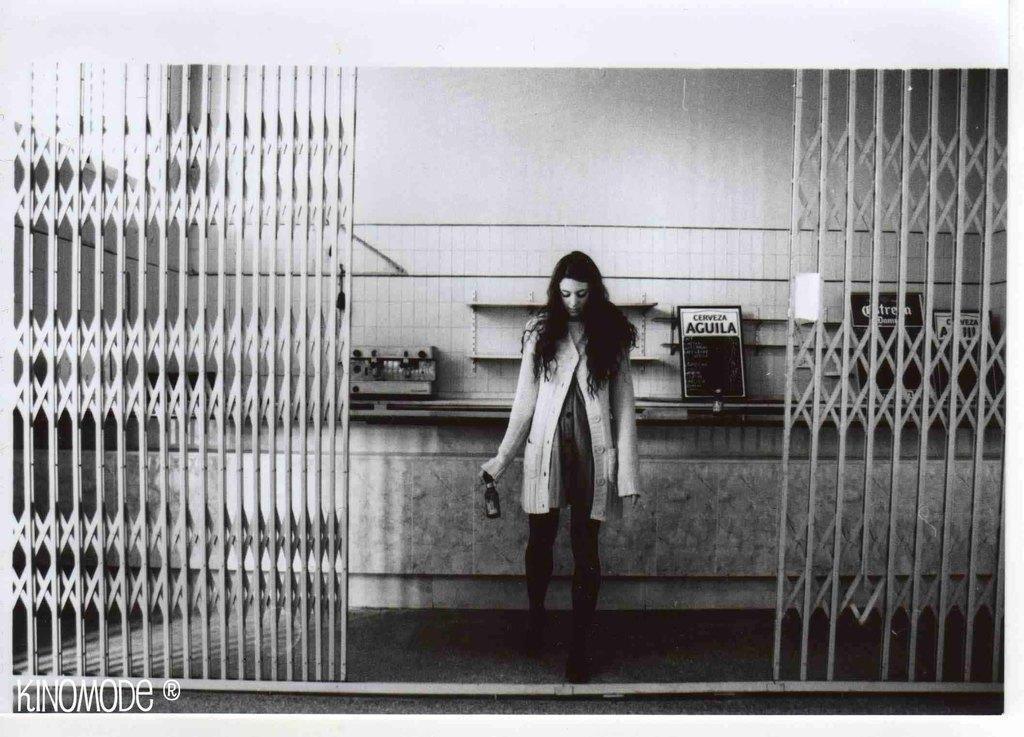Can you describe this image briefly? In this image there is a grill, in the background there is a woman standing on a floor and holding a bottle in her hand, in the background there is a wall for that wall there are some boards and objects, in the bottom left there is some text. 